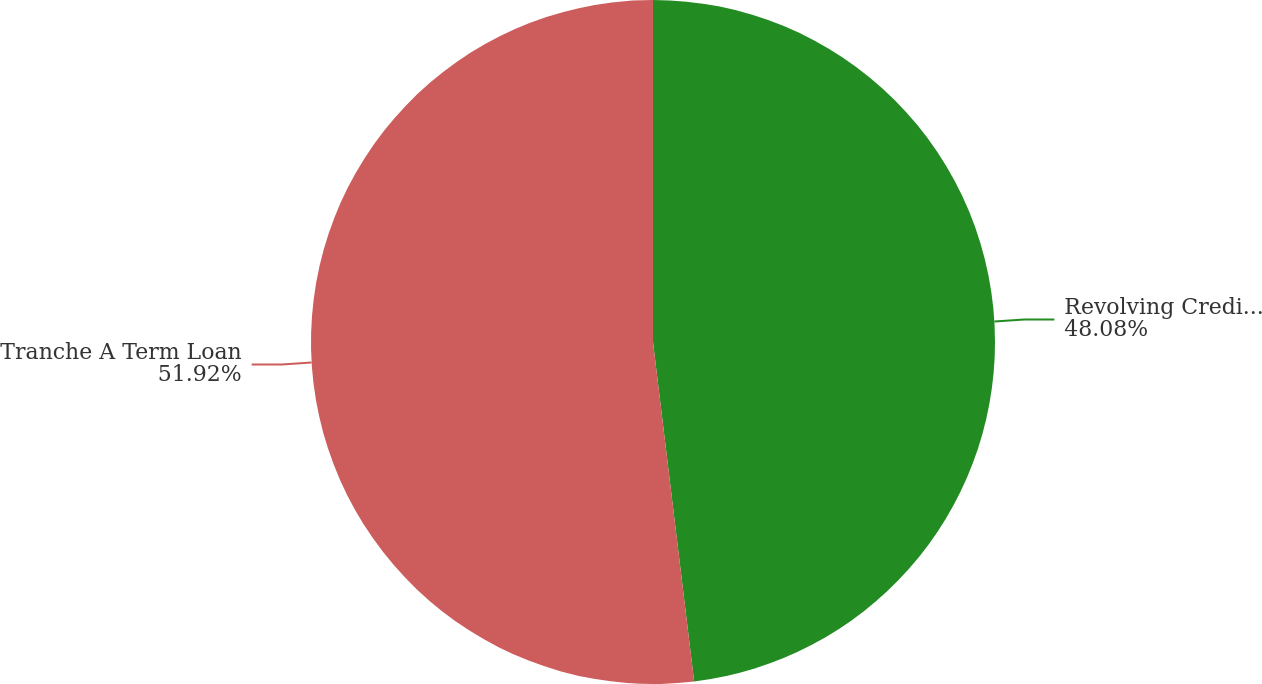Convert chart. <chart><loc_0><loc_0><loc_500><loc_500><pie_chart><fcel>Revolving Credit Facility<fcel>Tranche A Term Loan<nl><fcel>48.08%<fcel>51.92%<nl></chart> 